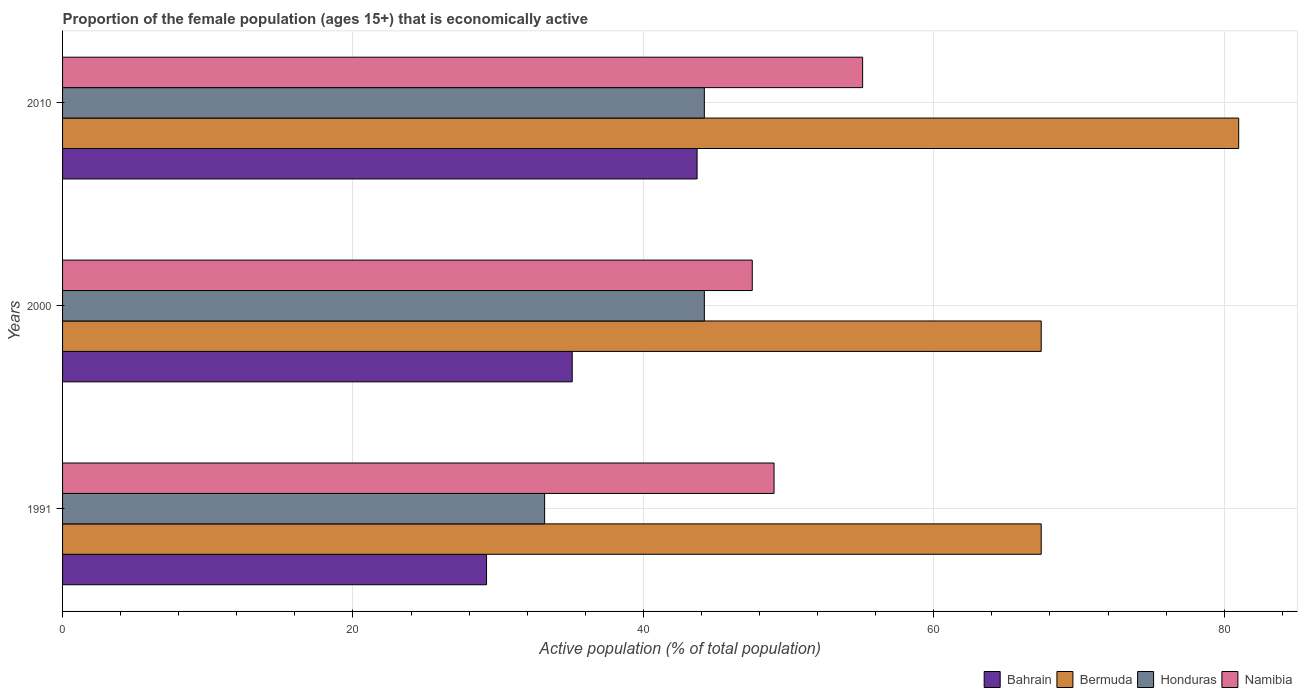Are the number of bars per tick equal to the number of legend labels?
Your answer should be compact. Yes. How many bars are there on the 1st tick from the bottom?
Make the answer very short. 4. In how many cases, is the number of bars for a given year not equal to the number of legend labels?
Keep it short and to the point. 0. What is the proportion of the female population that is economically active in Honduras in 2000?
Keep it short and to the point. 44.2. Across all years, what is the maximum proportion of the female population that is economically active in Honduras?
Give a very brief answer. 44.2. Across all years, what is the minimum proportion of the female population that is economically active in Honduras?
Your response must be concise. 33.2. In which year was the proportion of the female population that is economically active in Bermuda minimum?
Offer a very short reply. 1991. What is the total proportion of the female population that is economically active in Honduras in the graph?
Your answer should be compact. 121.6. What is the difference between the proportion of the female population that is economically active in Bermuda in 2000 and that in 2010?
Offer a terse response. -13.6. What is the difference between the proportion of the female population that is economically active in Bermuda in 2000 and the proportion of the female population that is economically active in Honduras in 1991?
Provide a short and direct response. 34.2. What is the average proportion of the female population that is economically active in Honduras per year?
Your answer should be very brief. 40.53. In the year 2010, what is the difference between the proportion of the female population that is economically active in Bermuda and proportion of the female population that is economically active in Honduras?
Provide a short and direct response. 36.8. What is the ratio of the proportion of the female population that is economically active in Honduras in 1991 to that in 2010?
Your answer should be very brief. 0.75. What is the difference between the highest and the second highest proportion of the female population that is economically active in Bahrain?
Provide a short and direct response. 8.6. In how many years, is the proportion of the female population that is economically active in Honduras greater than the average proportion of the female population that is economically active in Honduras taken over all years?
Provide a succinct answer. 2. Is it the case that in every year, the sum of the proportion of the female population that is economically active in Namibia and proportion of the female population that is economically active in Bahrain is greater than the sum of proportion of the female population that is economically active in Bermuda and proportion of the female population that is economically active in Honduras?
Ensure brevity in your answer.  No. What does the 4th bar from the top in 2000 represents?
Make the answer very short. Bahrain. What does the 1st bar from the bottom in 2000 represents?
Provide a succinct answer. Bahrain. Is it the case that in every year, the sum of the proportion of the female population that is economically active in Honduras and proportion of the female population that is economically active in Bermuda is greater than the proportion of the female population that is economically active in Namibia?
Offer a very short reply. Yes. Where does the legend appear in the graph?
Your answer should be very brief. Bottom right. What is the title of the graph?
Give a very brief answer. Proportion of the female population (ages 15+) that is economically active. Does "Japan" appear as one of the legend labels in the graph?
Offer a terse response. No. What is the label or title of the X-axis?
Keep it short and to the point. Active population (% of total population). What is the Active population (% of total population) of Bahrain in 1991?
Keep it short and to the point. 29.2. What is the Active population (% of total population) in Bermuda in 1991?
Offer a very short reply. 67.4. What is the Active population (% of total population) in Honduras in 1991?
Keep it short and to the point. 33.2. What is the Active population (% of total population) in Namibia in 1991?
Your answer should be compact. 49. What is the Active population (% of total population) in Bahrain in 2000?
Offer a very short reply. 35.1. What is the Active population (% of total population) in Bermuda in 2000?
Your answer should be very brief. 67.4. What is the Active population (% of total population) in Honduras in 2000?
Provide a short and direct response. 44.2. What is the Active population (% of total population) of Namibia in 2000?
Your response must be concise. 47.5. What is the Active population (% of total population) of Bahrain in 2010?
Provide a short and direct response. 43.7. What is the Active population (% of total population) of Honduras in 2010?
Your response must be concise. 44.2. What is the Active population (% of total population) of Namibia in 2010?
Your response must be concise. 55.1. Across all years, what is the maximum Active population (% of total population) of Bahrain?
Your answer should be very brief. 43.7. Across all years, what is the maximum Active population (% of total population) in Bermuda?
Offer a very short reply. 81. Across all years, what is the maximum Active population (% of total population) in Honduras?
Provide a succinct answer. 44.2. Across all years, what is the maximum Active population (% of total population) in Namibia?
Your response must be concise. 55.1. Across all years, what is the minimum Active population (% of total population) in Bahrain?
Provide a short and direct response. 29.2. Across all years, what is the minimum Active population (% of total population) of Bermuda?
Offer a very short reply. 67.4. Across all years, what is the minimum Active population (% of total population) in Honduras?
Ensure brevity in your answer.  33.2. Across all years, what is the minimum Active population (% of total population) in Namibia?
Give a very brief answer. 47.5. What is the total Active population (% of total population) of Bahrain in the graph?
Provide a succinct answer. 108. What is the total Active population (% of total population) of Bermuda in the graph?
Make the answer very short. 215.8. What is the total Active population (% of total population) in Honduras in the graph?
Provide a short and direct response. 121.6. What is the total Active population (% of total population) in Namibia in the graph?
Make the answer very short. 151.6. What is the difference between the Active population (% of total population) of Bahrain in 1991 and that in 2000?
Keep it short and to the point. -5.9. What is the difference between the Active population (% of total population) of Bermuda in 1991 and that in 2000?
Your answer should be compact. 0. What is the difference between the Active population (% of total population) in Namibia in 1991 and that in 2000?
Your response must be concise. 1.5. What is the difference between the Active population (% of total population) of Bahrain in 1991 and that in 2010?
Provide a succinct answer. -14.5. What is the difference between the Active population (% of total population) of Namibia in 1991 and that in 2010?
Offer a terse response. -6.1. What is the difference between the Active population (% of total population) in Bahrain in 2000 and that in 2010?
Your answer should be very brief. -8.6. What is the difference between the Active population (% of total population) in Honduras in 2000 and that in 2010?
Offer a terse response. 0. What is the difference between the Active population (% of total population) in Bahrain in 1991 and the Active population (% of total population) in Bermuda in 2000?
Your answer should be compact. -38.2. What is the difference between the Active population (% of total population) of Bahrain in 1991 and the Active population (% of total population) of Honduras in 2000?
Your answer should be compact. -15. What is the difference between the Active population (% of total population) in Bahrain in 1991 and the Active population (% of total population) in Namibia in 2000?
Provide a succinct answer. -18.3. What is the difference between the Active population (% of total population) of Bermuda in 1991 and the Active population (% of total population) of Honduras in 2000?
Offer a very short reply. 23.2. What is the difference between the Active population (% of total population) in Honduras in 1991 and the Active population (% of total population) in Namibia in 2000?
Keep it short and to the point. -14.3. What is the difference between the Active population (% of total population) in Bahrain in 1991 and the Active population (% of total population) in Bermuda in 2010?
Your answer should be very brief. -51.8. What is the difference between the Active population (% of total population) in Bahrain in 1991 and the Active population (% of total population) in Namibia in 2010?
Offer a terse response. -25.9. What is the difference between the Active population (% of total population) of Bermuda in 1991 and the Active population (% of total population) of Honduras in 2010?
Your answer should be very brief. 23.2. What is the difference between the Active population (% of total population) of Honduras in 1991 and the Active population (% of total population) of Namibia in 2010?
Provide a succinct answer. -21.9. What is the difference between the Active population (% of total population) of Bahrain in 2000 and the Active population (% of total population) of Bermuda in 2010?
Your answer should be compact. -45.9. What is the difference between the Active population (% of total population) in Bahrain in 2000 and the Active population (% of total population) in Honduras in 2010?
Keep it short and to the point. -9.1. What is the difference between the Active population (% of total population) of Bahrain in 2000 and the Active population (% of total population) of Namibia in 2010?
Keep it short and to the point. -20. What is the difference between the Active population (% of total population) of Bermuda in 2000 and the Active population (% of total population) of Honduras in 2010?
Provide a succinct answer. 23.2. What is the difference between the Active population (% of total population) of Bermuda in 2000 and the Active population (% of total population) of Namibia in 2010?
Offer a terse response. 12.3. What is the average Active population (% of total population) of Bermuda per year?
Offer a terse response. 71.93. What is the average Active population (% of total population) of Honduras per year?
Your response must be concise. 40.53. What is the average Active population (% of total population) of Namibia per year?
Offer a very short reply. 50.53. In the year 1991, what is the difference between the Active population (% of total population) in Bahrain and Active population (% of total population) in Bermuda?
Give a very brief answer. -38.2. In the year 1991, what is the difference between the Active population (% of total population) in Bahrain and Active population (% of total population) in Honduras?
Your response must be concise. -4. In the year 1991, what is the difference between the Active population (% of total population) in Bahrain and Active population (% of total population) in Namibia?
Provide a succinct answer. -19.8. In the year 1991, what is the difference between the Active population (% of total population) of Bermuda and Active population (% of total population) of Honduras?
Keep it short and to the point. 34.2. In the year 1991, what is the difference between the Active population (% of total population) in Bermuda and Active population (% of total population) in Namibia?
Your answer should be compact. 18.4. In the year 1991, what is the difference between the Active population (% of total population) of Honduras and Active population (% of total population) of Namibia?
Keep it short and to the point. -15.8. In the year 2000, what is the difference between the Active population (% of total population) of Bahrain and Active population (% of total population) of Bermuda?
Make the answer very short. -32.3. In the year 2000, what is the difference between the Active population (% of total population) of Bahrain and Active population (% of total population) of Namibia?
Provide a short and direct response. -12.4. In the year 2000, what is the difference between the Active population (% of total population) in Bermuda and Active population (% of total population) in Honduras?
Your answer should be very brief. 23.2. In the year 2000, what is the difference between the Active population (% of total population) of Bermuda and Active population (% of total population) of Namibia?
Offer a terse response. 19.9. In the year 2010, what is the difference between the Active population (% of total population) in Bahrain and Active population (% of total population) in Bermuda?
Provide a succinct answer. -37.3. In the year 2010, what is the difference between the Active population (% of total population) in Bahrain and Active population (% of total population) in Namibia?
Offer a very short reply. -11.4. In the year 2010, what is the difference between the Active population (% of total population) in Bermuda and Active population (% of total population) in Honduras?
Provide a succinct answer. 36.8. In the year 2010, what is the difference between the Active population (% of total population) in Bermuda and Active population (% of total population) in Namibia?
Ensure brevity in your answer.  25.9. In the year 2010, what is the difference between the Active population (% of total population) in Honduras and Active population (% of total population) in Namibia?
Provide a succinct answer. -10.9. What is the ratio of the Active population (% of total population) in Bahrain in 1991 to that in 2000?
Keep it short and to the point. 0.83. What is the ratio of the Active population (% of total population) of Honduras in 1991 to that in 2000?
Keep it short and to the point. 0.75. What is the ratio of the Active population (% of total population) of Namibia in 1991 to that in 2000?
Keep it short and to the point. 1.03. What is the ratio of the Active population (% of total population) in Bahrain in 1991 to that in 2010?
Your response must be concise. 0.67. What is the ratio of the Active population (% of total population) in Bermuda in 1991 to that in 2010?
Give a very brief answer. 0.83. What is the ratio of the Active population (% of total population) of Honduras in 1991 to that in 2010?
Your response must be concise. 0.75. What is the ratio of the Active population (% of total population) in Namibia in 1991 to that in 2010?
Provide a succinct answer. 0.89. What is the ratio of the Active population (% of total population) of Bahrain in 2000 to that in 2010?
Offer a very short reply. 0.8. What is the ratio of the Active population (% of total population) of Bermuda in 2000 to that in 2010?
Offer a terse response. 0.83. What is the ratio of the Active population (% of total population) of Namibia in 2000 to that in 2010?
Your answer should be very brief. 0.86. What is the difference between the highest and the second highest Active population (% of total population) in Honduras?
Keep it short and to the point. 0. What is the difference between the highest and the lowest Active population (% of total population) in Honduras?
Provide a short and direct response. 11. 